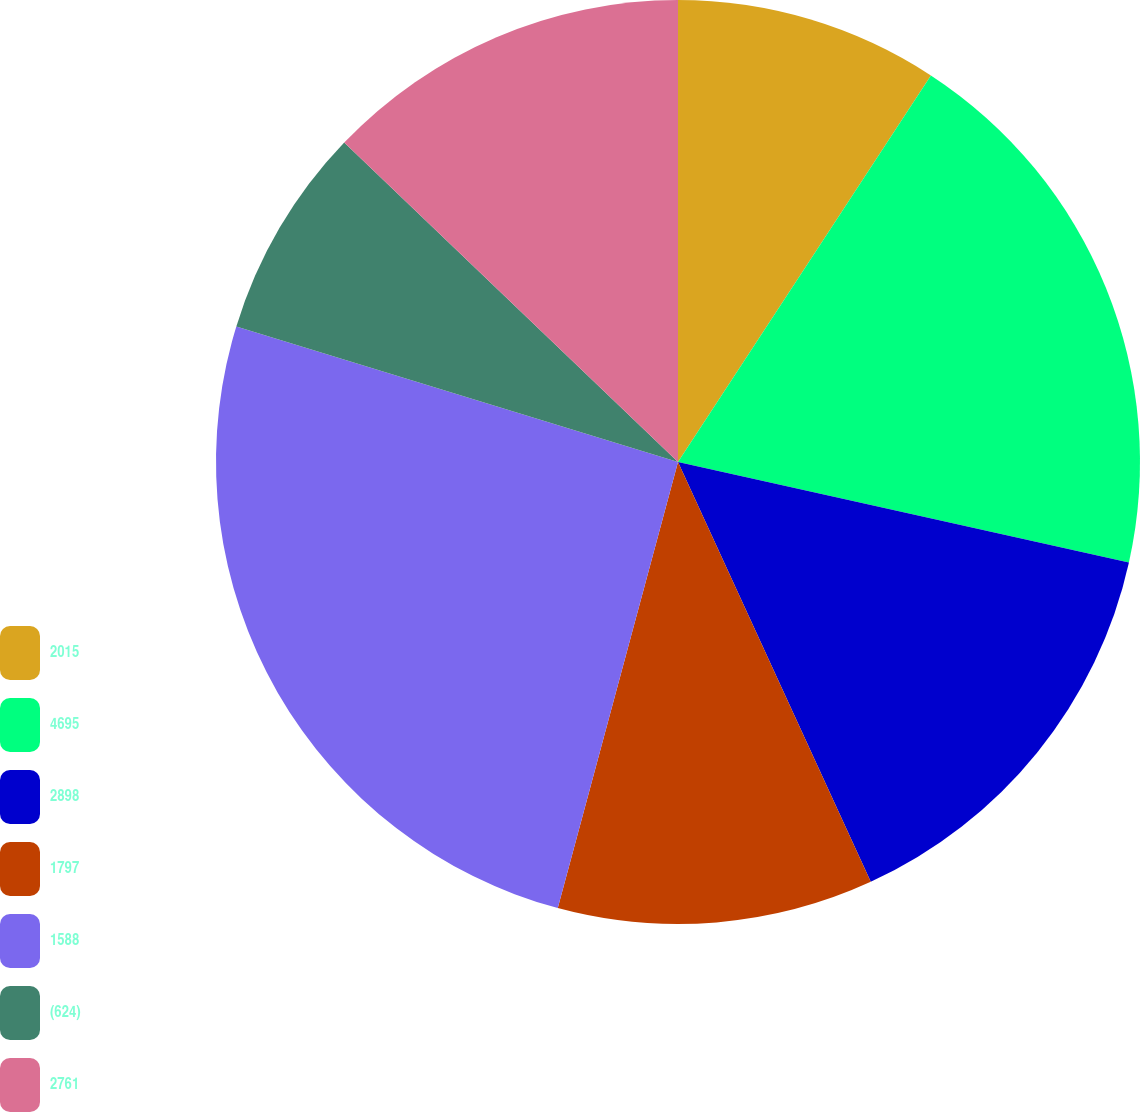<chart> <loc_0><loc_0><loc_500><loc_500><pie_chart><fcel>2015<fcel>4695<fcel>2898<fcel>1797<fcel>1588<fcel>(624)<fcel>2761<nl><fcel>9.22%<fcel>19.27%<fcel>14.66%<fcel>11.04%<fcel>25.55%<fcel>7.41%<fcel>12.85%<nl></chart> 